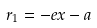Convert formula to latex. <formula><loc_0><loc_0><loc_500><loc_500>r _ { 1 } = - e x - a</formula> 